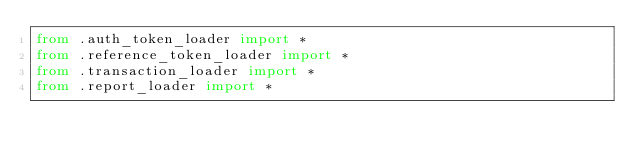<code> <loc_0><loc_0><loc_500><loc_500><_Python_>from .auth_token_loader import *
from .reference_token_loader import *
from .transaction_loader import *
from .report_loader import *
</code> 